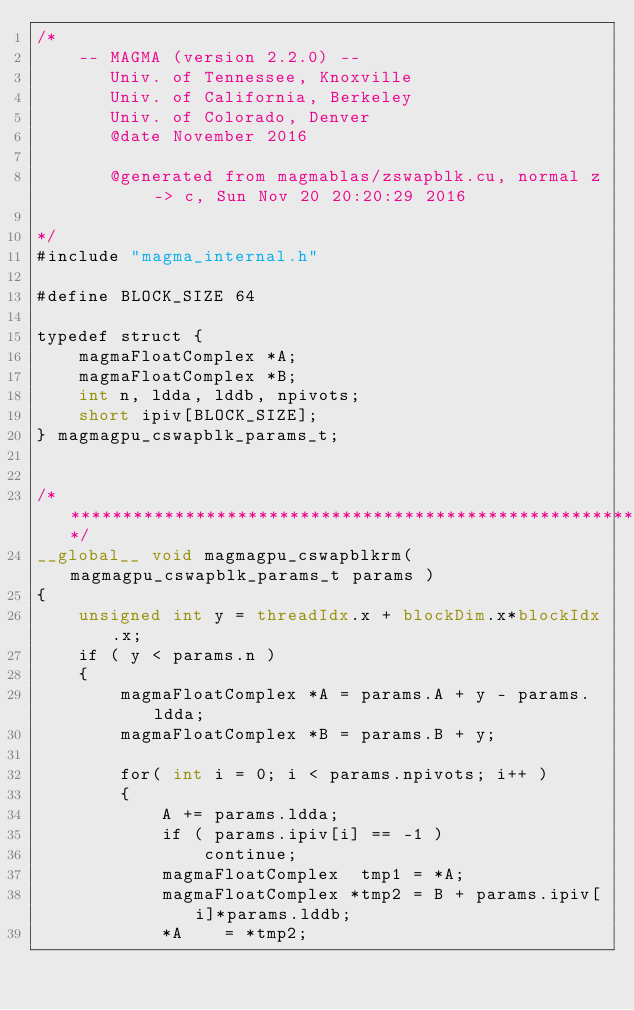Convert code to text. <code><loc_0><loc_0><loc_500><loc_500><_Cuda_>/*
    -- MAGMA (version 2.2.0) --
       Univ. of Tennessee, Knoxville
       Univ. of California, Berkeley
       Univ. of Colorado, Denver
       @date November 2016

       @generated from magmablas/zswapblk.cu, normal z -> c, Sun Nov 20 20:20:29 2016

*/
#include "magma_internal.h"

#define BLOCK_SIZE 64

typedef struct {
    magmaFloatComplex *A;
    magmaFloatComplex *B;
    int n, ldda, lddb, npivots;
    short ipiv[BLOCK_SIZE];
} magmagpu_cswapblk_params_t;


/******************************************************************************/
__global__ void magmagpu_cswapblkrm( magmagpu_cswapblk_params_t params )
{
    unsigned int y = threadIdx.x + blockDim.x*blockIdx.x;
    if ( y < params.n )
    {
        magmaFloatComplex *A = params.A + y - params.ldda;
        magmaFloatComplex *B = params.B + y;
      
        for( int i = 0; i < params.npivots; i++ )
        {
            A += params.ldda;
            if ( params.ipiv[i] == -1 )
                continue;
            magmaFloatComplex  tmp1 = *A;
            magmaFloatComplex *tmp2 = B + params.ipiv[i]*params.lddb;
            *A    = *tmp2;</code> 